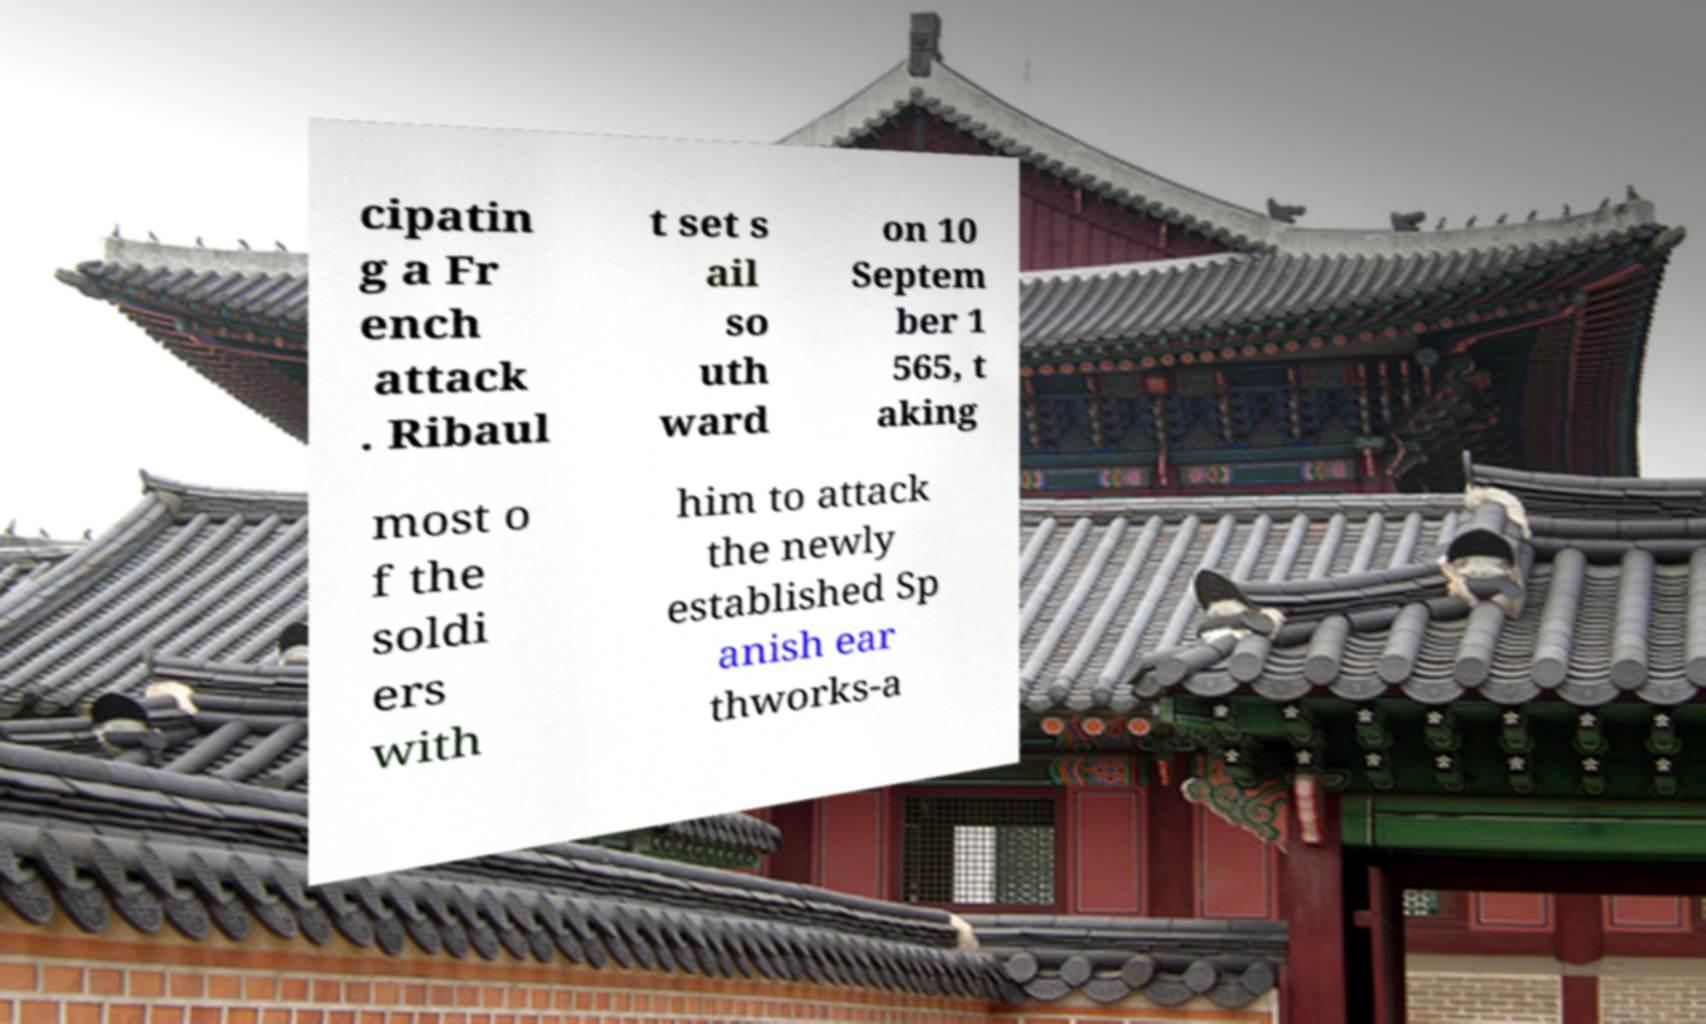Can you read and provide the text displayed in the image?This photo seems to have some interesting text. Can you extract and type it out for me? cipatin g a Fr ench attack . Ribaul t set s ail so uth ward on 10 Septem ber 1 565, t aking most o f the soldi ers with him to attack the newly established Sp anish ear thworks-a 